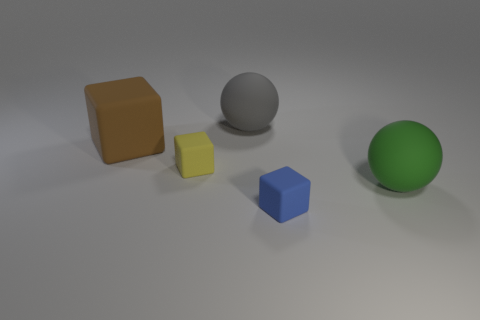There is a matte sphere on the right side of the large sphere that is to the left of the blue matte block; what is its size?
Keep it short and to the point. Large. How many other objects are the same size as the blue matte cube?
Your response must be concise. 1. There is a blue rubber object that is the same shape as the small yellow rubber object; what is its size?
Offer a terse response. Small. Do the big green ball and the small object behind the blue thing have the same material?
Give a very brief answer. Yes. What number of purple things are either small things or spheres?
Provide a short and direct response. 0. Is there a blue shiny thing of the same size as the gray rubber object?
Your answer should be very brief. No. The small object to the left of the sphere that is to the left of the thing that is right of the tiny blue rubber cube is made of what material?
Give a very brief answer. Rubber. Are there the same number of big gray rubber spheres that are in front of the gray rubber ball and tiny red cylinders?
Ensure brevity in your answer.  Yes. Do the ball on the left side of the blue rubber thing and the tiny cube that is on the right side of the yellow thing have the same material?
Your answer should be very brief. Yes. How many things are either small brown spheres or balls behind the brown object?
Your response must be concise. 1. 